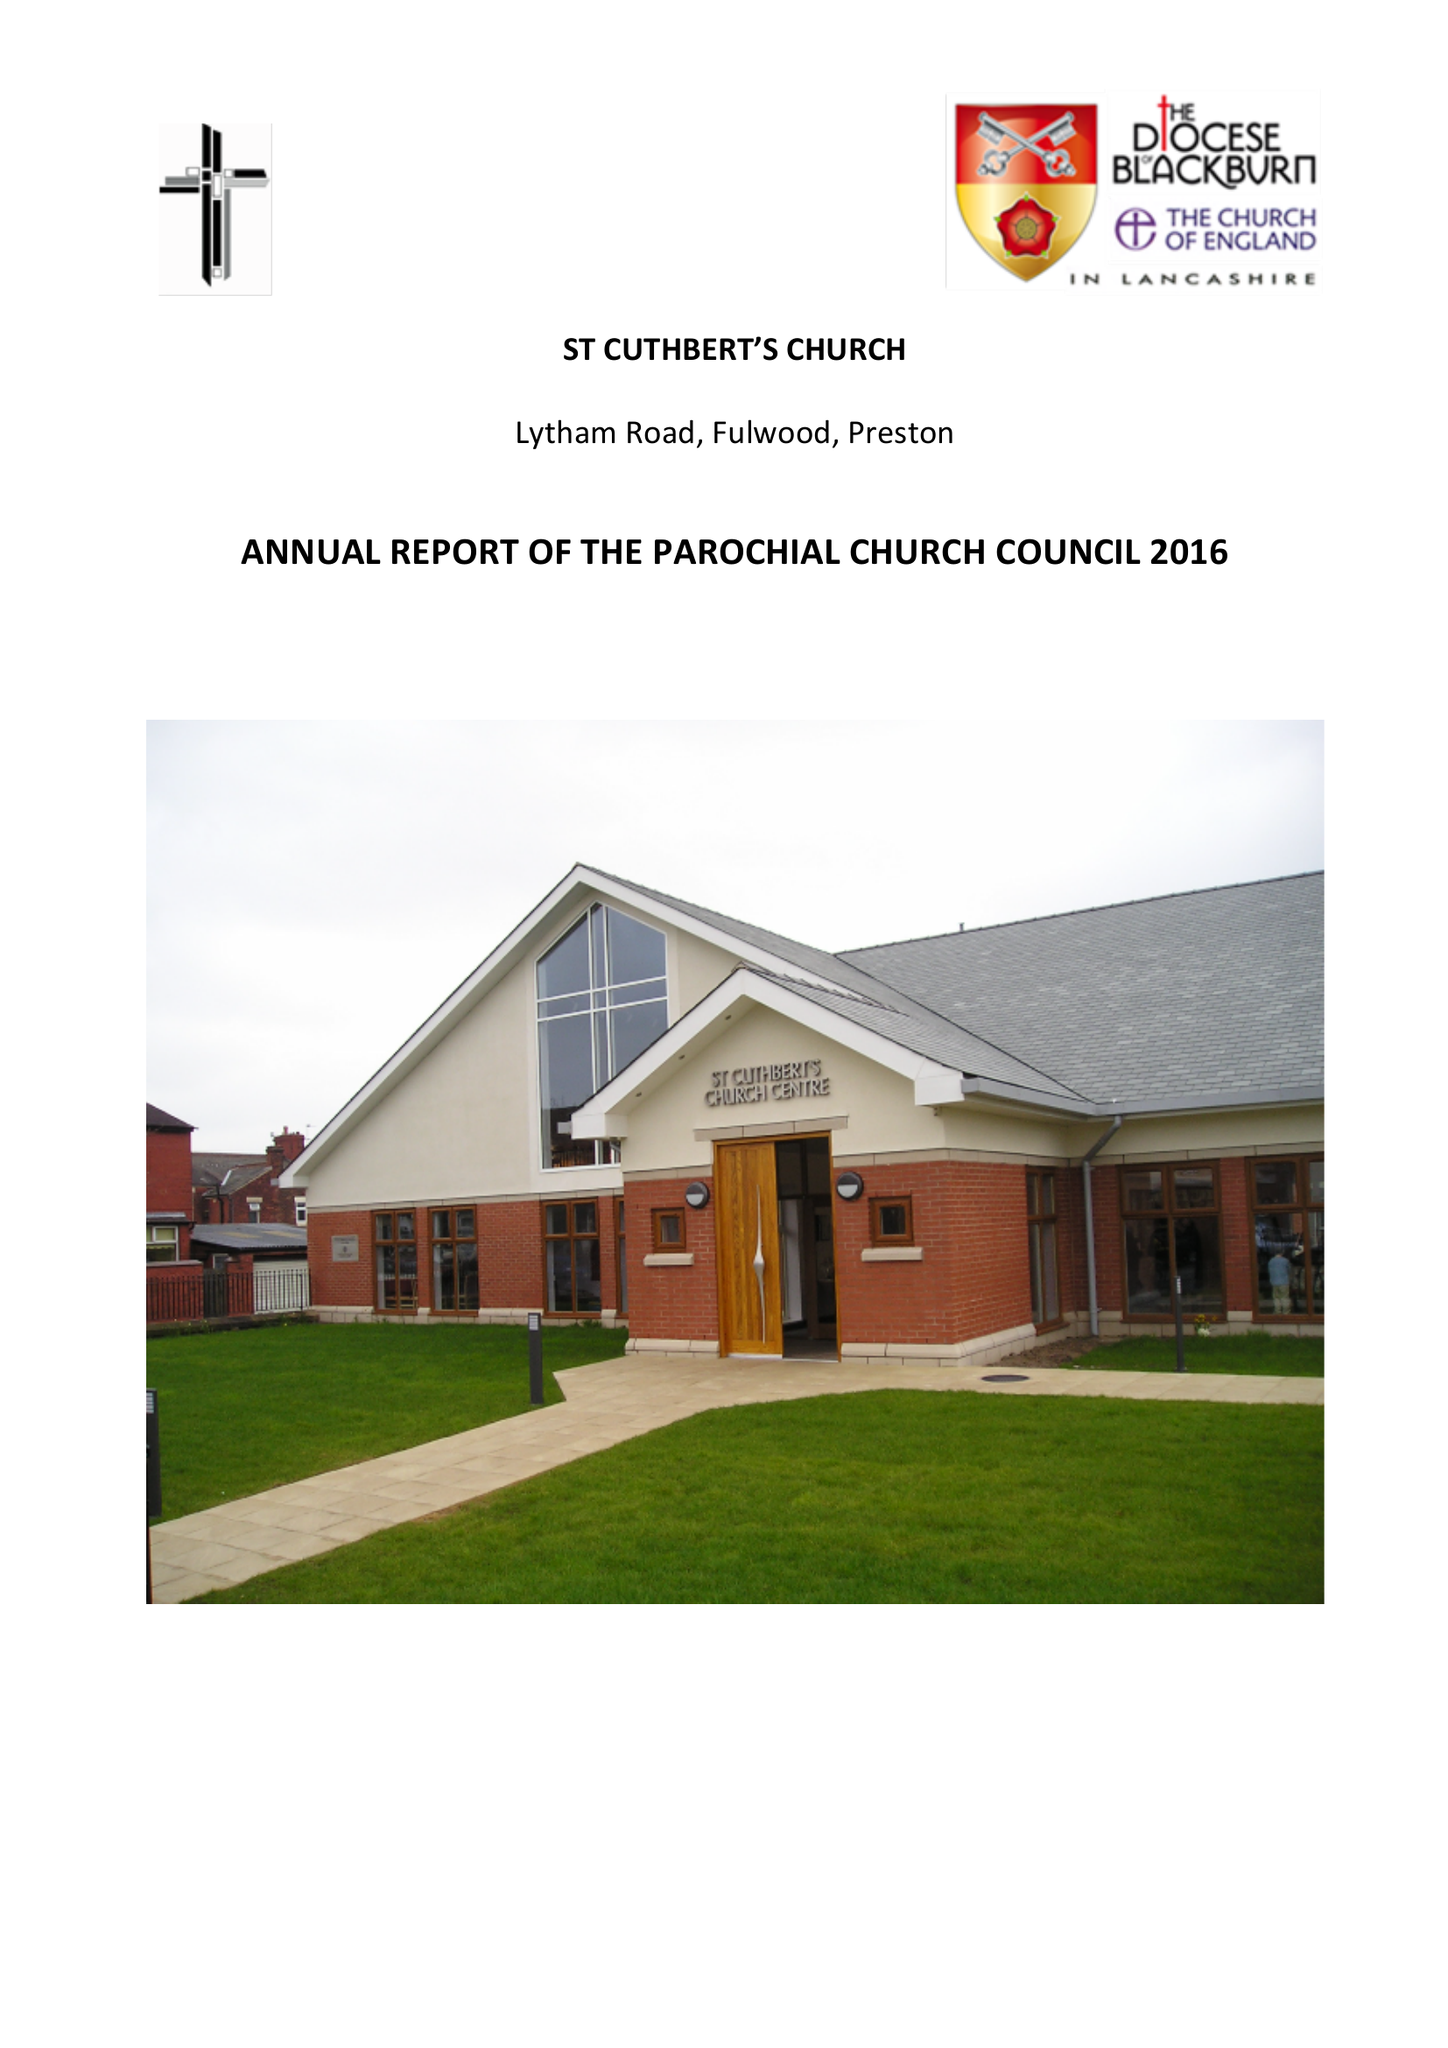What is the value for the spending_annually_in_british_pounds?
Answer the question using a single word or phrase. 130544.98 